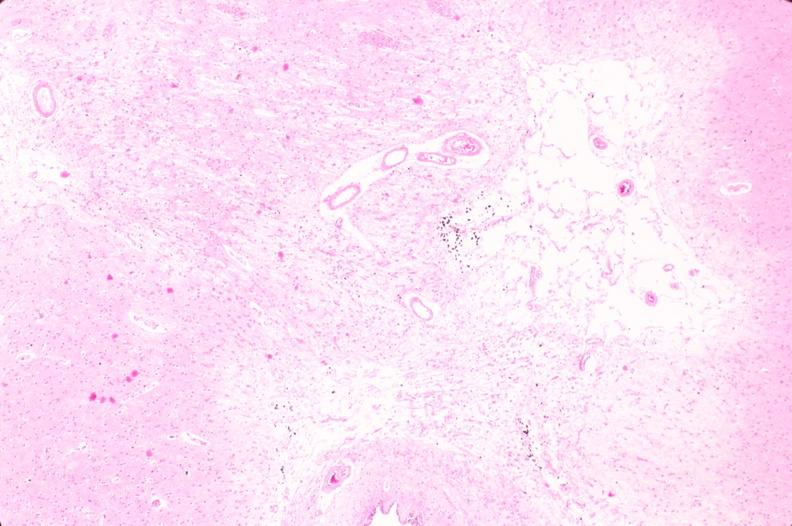what is present?
Answer the question using a single word or phrase. Nervous 